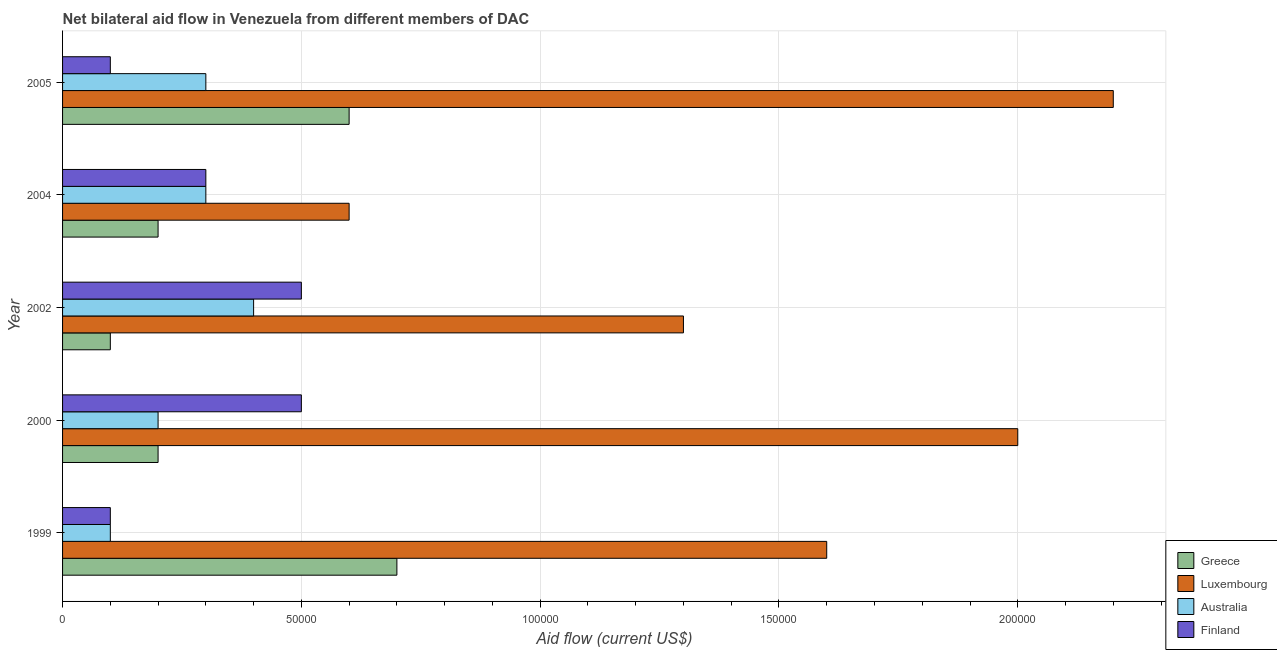How many different coloured bars are there?
Your answer should be compact. 4. Are the number of bars per tick equal to the number of legend labels?
Your answer should be compact. Yes. Are the number of bars on each tick of the Y-axis equal?
Your response must be concise. Yes. How many bars are there on the 1st tick from the bottom?
Offer a very short reply. 4. What is the label of the 1st group of bars from the top?
Provide a short and direct response. 2005. In how many cases, is the number of bars for a given year not equal to the number of legend labels?
Provide a short and direct response. 0. What is the amount of aid given by luxembourg in 2004?
Provide a short and direct response. 6.00e+04. Across all years, what is the maximum amount of aid given by greece?
Ensure brevity in your answer.  7.00e+04. Across all years, what is the minimum amount of aid given by australia?
Provide a succinct answer. 10000. What is the total amount of aid given by australia in the graph?
Provide a short and direct response. 1.30e+05. What is the difference between the amount of aid given by australia in 1999 and that in 2005?
Keep it short and to the point. -2.00e+04. What is the difference between the amount of aid given by finland in 2000 and the amount of aid given by greece in 1999?
Make the answer very short. -2.00e+04. In the year 2002, what is the difference between the amount of aid given by finland and amount of aid given by greece?
Provide a short and direct response. 4.00e+04. Is the difference between the amount of aid given by australia in 2000 and 2002 greater than the difference between the amount of aid given by finland in 2000 and 2002?
Offer a very short reply. No. What is the difference between the highest and the second highest amount of aid given by greece?
Offer a terse response. 10000. What is the difference between the highest and the lowest amount of aid given by greece?
Your answer should be compact. 6.00e+04. Is it the case that in every year, the sum of the amount of aid given by greece and amount of aid given by australia is greater than the sum of amount of aid given by finland and amount of aid given by luxembourg?
Offer a terse response. No. How many years are there in the graph?
Provide a succinct answer. 5. What is the difference between two consecutive major ticks on the X-axis?
Your answer should be compact. 5.00e+04. Does the graph contain any zero values?
Provide a short and direct response. No. Where does the legend appear in the graph?
Provide a succinct answer. Bottom right. How are the legend labels stacked?
Offer a very short reply. Vertical. What is the title of the graph?
Make the answer very short. Net bilateral aid flow in Venezuela from different members of DAC. What is the label or title of the Y-axis?
Make the answer very short. Year. What is the Aid flow (current US$) of Australia in 1999?
Your response must be concise. 10000. What is the Aid flow (current US$) of Finland in 1999?
Provide a short and direct response. 10000. What is the Aid flow (current US$) in Greece in 2000?
Provide a succinct answer. 2.00e+04. What is the Aid flow (current US$) in Australia in 2000?
Your response must be concise. 2.00e+04. What is the Aid flow (current US$) of Finland in 2000?
Provide a succinct answer. 5.00e+04. What is the Aid flow (current US$) of Luxembourg in 2002?
Your answer should be very brief. 1.30e+05. What is the Aid flow (current US$) in Finland in 2002?
Provide a short and direct response. 5.00e+04. What is the Aid flow (current US$) of Luxembourg in 2004?
Offer a very short reply. 6.00e+04. What is the Aid flow (current US$) in Finland in 2004?
Offer a terse response. 3.00e+04. What is the Aid flow (current US$) in Luxembourg in 2005?
Offer a very short reply. 2.20e+05. What is the Aid flow (current US$) of Australia in 2005?
Your answer should be compact. 3.00e+04. What is the Aid flow (current US$) of Finland in 2005?
Your answer should be compact. 10000. Across all years, what is the maximum Aid flow (current US$) in Australia?
Make the answer very short. 4.00e+04. Across all years, what is the maximum Aid flow (current US$) in Finland?
Offer a terse response. 5.00e+04. Across all years, what is the minimum Aid flow (current US$) in Luxembourg?
Offer a very short reply. 6.00e+04. Across all years, what is the minimum Aid flow (current US$) of Finland?
Offer a terse response. 10000. What is the total Aid flow (current US$) in Luxembourg in the graph?
Offer a terse response. 7.70e+05. What is the total Aid flow (current US$) in Finland in the graph?
Make the answer very short. 1.50e+05. What is the difference between the Aid flow (current US$) in Greece in 1999 and that in 2000?
Your response must be concise. 5.00e+04. What is the difference between the Aid flow (current US$) of Finland in 1999 and that in 2000?
Give a very brief answer. -4.00e+04. What is the difference between the Aid flow (current US$) in Luxembourg in 1999 and that in 2002?
Offer a very short reply. 3.00e+04. What is the difference between the Aid flow (current US$) of Australia in 1999 and that in 2005?
Ensure brevity in your answer.  -2.00e+04. What is the difference between the Aid flow (current US$) of Greece in 2000 and that in 2002?
Offer a very short reply. 10000. What is the difference between the Aid flow (current US$) in Finland in 2000 and that in 2002?
Make the answer very short. 0. What is the difference between the Aid flow (current US$) in Greece in 2000 and that in 2004?
Make the answer very short. 0. What is the difference between the Aid flow (current US$) in Luxembourg in 2000 and that in 2004?
Offer a terse response. 1.40e+05. What is the difference between the Aid flow (current US$) of Australia in 2000 and that in 2004?
Your answer should be very brief. -10000. What is the difference between the Aid flow (current US$) in Finland in 2000 and that in 2004?
Make the answer very short. 2.00e+04. What is the difference between the Aid flow (current US$) in Greece in 2000 and that in 2005?
Keep it short and to the point. -4.00e+04. What is the difference between the Aid flow (current US$) in Luxembourg in 2000 and that in 2005?
Your response must be concise. -2.00e+04. What is the difference between the Aid flow (current US$) in Finland in 2000 and that in 2005?
Your answer should be compact. 4.00e+04. What is the difference between the Aid flow (current US$) of Greece in 2002 and that in 2004?
Your answer should be very brief. -10000. What is the difference between the Aid flow (current US$) in Australia in 2002 and that in 2004?
Your answer should be very brief. 10000. What is the difference between the Aid flow (current US$) of Greece in 2002 and that in 2005?
Ensure brevity in your answer.  -5.00e+04. What is the difference between the Aid flow (current US$) of Luxembourg in 2002 and that in 2005?
Your answer should be very brief. -9.00e+04. What is the difference between the Aid flow (current US$) in Australia in 2002 and that in 2005?
Offer a very short reply. 10000. What is the difference between the Aid flow (current US$) of Finland in 2002 and that in 2005?
Your response must be concise. 4.00e+04. What is the difference between the Aid flow (current US$) of Greece in 2004 and that in 2005?
Offer a terse response. -4.00e+04. What is the difference between the Aid flow (current US$) of Luxembourg in 2004 and that in 2005?
Make the answer very short. -1.60e+05. What is the difference between the Aid flow (current US$) of Australia in 2004 and that in 2005?
Your answer should be very brief. 0. What is the difference between the Aid flow (current US$) in Greece in 1999 and the Aid flow (current US$) in Australia in 2000?
Your answer should be very brief. 5.00e+04. What is the difference between the Aid flow (current US$) in Luxembourg in 1999 and the Aid flow (current US$) in Finland in 2000?
Make the answer very short. 1.10e+05. What is the difference between the Aid flow (current US$) of Greece in 1999 and the Aid flow (current US$) of Luxembourg in 2002?
Offer a terse response. -6.00e+04. What is the difference between the Aid flow (current US$) of Australia in 1999 and the Aid flow (current US$) of Finland in 2002?
Your response must be concise. -4.00e+04. What is the difference between the Aid flow (current US$) of Greece in 1999 and the Aid flow (current US$) of Luxembourg in 2004?
Make the answer very short. 10000. What is the difference between the Aid flow (current US$) in Greece in 1999 and the Aid flow (current US$) in Australia in 2004?
Your answer should be compact. 4.00e+04. What is the difference between the Aid flow (current US$) in Greece in 1999 and the Aid flow (current US$) in Finland in 2004?
Offer a very short reply. 4.00e+04. What is the difference between the Aid flow (current US$) of Luxembourg in 1999 and the Aid flow (current US$) of Finland in 2004?
Your answer should be compact. 1.30e+05. What is the difference between the Aid flow (current US$) of Greece in 1999 and the Aid flow (current US$) of Luxembourg in 2005?
Your answer should be compact. -1.50e+05. What is the difference between the Aid flow (current US$) in Greece in 1999 and the Aid flow (current US$) in Australia in 2005?
Offer a terse response. 4.00e+04. What is the difference between the Aid flow (current US$) of Greece in 1999 and the Aid flow (current US$) of Finland in 2005?
Offer a terse response. 6.00e+04. What is the difference between the Aid flow (current US$) of Luxembourg in 1999 and the Aid flow (current US$) of Finland in 2005?
Keep it short and to the point. 1.50e+05. What is the difference between the Aid flow (current US$) in Greece in 2000 and the Aid flow (current US$) in Luxembourg in 2002?
Your answer should be very brief. -1.10e+05. What is the difference between the Aid flow (current US$) in Luxembourg in 2000 and the Aid flow (current US$) in Finland in 2002?
Your answer should be compact. 1.50e+05. What is the difference between the Aid flow (current US$) of Australia in 2000 and the Aid flow (current US$) of Finland in 2002?
Keep it short and to the point. -3.00e+04. What is the difference between the Aid flow (current US$) in Greece in 2000 and the Aid flow (current US$) in Australia in 2004?
Make the answer very short. -10000. What is the difference between the Aid flow (current US$) in Greece in 2000 and the Aid flow (current US$) in Finland in 2004?
Offer a very short reply. -10000. What is the difference between the Aid flow (current US$) of Luxembourg in 2000 and the Aid flow (current US$) of Australia in 2004?
Offer a terse response. 1.70e+05. What is the difference between the Aid flow (current US$) in Luxembourg in 2000 and the Aid flow (current US$) in Finland in 2004?
Your answer should be very brief. 1.70e+05. What is the difference between the Aid flow (current US$) of Greece in 2000 and the Aid flow (current US$) of Luxembourg in 2005?
Give a very brief answer. -2.00e+05. What is the difference between the Aid flow (current US$) of Greece in 2000 and the Aid flow (current US$) of Australia in 2005?
Ensure brevity in your answer.  -10000. What is the difference between the Aid flow (current US$) in Greece in 2002 and the Aid flow (current US$) in Luxembourg in 2004?
Give a very brief answer. -5.00e+04. What is the difference between the Aid flow (current US$) of Greece in 2002 and the Aid flow (current US$) of Australia in 2004?
Provide a succinct answer. -2.00e+04. What is the difference between the Aid flow (current US$) in Greece in 2002 and the Aid flow (current US$) in Finland in 2004?
Provide a short and direct response. -2.00e+04. What is the difference between the Aid flow (current US$) of Luxembourg in 2002 and the Aid flow (current US$) of Finland in 2004?
Make the answer very short. 1.00e+05. What is the difference between the Aid flow (current US$) in Greece in 2002 and the Aid flow (current US$) in Luxembourg in 2005?
Give a very brief answer. -2.10e+05. What is the difference between the Aid flow (current US$) of Greece in 2002 and the Aid flow (current US$) of Australia in 2005?
Offer a very short reply. -2.00e+04. What is the difference between the Aid flow (current US$) in Greece in 2002 and the Aid flow (current US$) in Finland in 2005?
Your answer should be compact. 0. What is the difference between the Aid flow (current US$) of Luxembourg in 2002 and the Aid flow (current US$) of Finland in 2005?
Provide a succinct answer. 1.20e+05. What is the difference between the Aid flow (current US$) in Australia in 2002 and the Aid flow (current US$) in Finland in 2005?
Keep it short and to the point. 3.00e+04. What is the difference between the Aid flow (current US$) of Greece in 2004 and the Aid flow (current US$) of Luxembourg in 2005?
Your response must be concise. -2.00e+05. What is the difference between the Aid flow (current US$) in Australia in 2004 and the Aid flow (current US$) in Finland in 2005?
Offer a very short reply. 2.00e+04. What is the average Aid flow (current US$) of Greece per year?
Your answer should be very brief. 3.60e+04. What is the average Aid flow (current US$) of Luxembourg per year?
Ensure brevity in your answer.  1.54e+05. What is the average Aid flow (current US$) in Australia per year?
Your response must be concise. 2.60e+04. In the year 1999, what is the difference between the Aid flow (current US$) of Greece and Aid flow (current US$) of Finland?
Give a very brief answer. 6.00e+04. In the year 2000, what is the difference between the Aid flow (current US$) of Greece and Aid flow (current US$) of Luxembourg?
Provide a short and direct response. -1.80e+05. In the year 2000, what is the difference between the Aid flow (current US$) in Greece and Aid flow (current US$) in Australia?
Your answer should be very brief. 0. In the year 2000, what is the difference between the Aid flow (current US$) in Australia and Aid flow (current US$) in Finland?
Give a very brief answer. -3.00e+04. In the year 2002, what is the difference between the Aid flow (current US$) in Greece and Aid flow (current US$) in Luxembourg?
Provide a short and direct response. -1.20e+05. In the year 2002, what is the difference between the Aid flow (current US$) in Luxembourg and Aid flow (current US$) in Australia?
Make the answer very short. 9.00e+04. In the year 2002, what is the difference between the Aid flow (current US$) in Australia and Aid flow (current US$) in Finland?
Provide a short and direct response. -10000. In the year 2004, what is the difference between the Aid flow (current US$) in Greece and Aid flow (current US$) in Australia?
Your response must be concise. -10000. In the year 2004, what is the difference between the Aid flow (current US$) in Luxembourg and Aid flow (current US$) in Finland?
Provide a short and direct response. 3.00e+04. In the year 2004, what is the difference between the Aid flow (current US$) in Australia and Aid flow (current US$) in Finland?
Your answer should be compact. 0. In the year 2005, what is the difference between the Aid flow (current US$) of Greece and Aid flow (current US$) of Australia?
Ensure brevity in your answer.  3.00e+04. In the year 2005, what is the difference between the Aid flow (current US$) of Luxembourg and Aid flow (current US$) of Finland?
Offer a terse response. 2.10e+05. What is the ratio of the Aid flow (current US$) in Luxembourg in 1999 to that in 2000?
Your answer should be very brief. 0.8. What is the ratio of the Aid flow (current US$) of Australia in 1999 to that in 2000?
Make the answer very short. 0.5. What is the ratio of the Aid flow (current US$) in Greece in 1999 to that in 2002?
Provide a succinct answer. 7. What is the ratio of the Aid flow (current US$) in Luxembourg in 1999 to that in 2002?
Ensure brevity in your answer.  1.23. What is the ratio of the Aid flow (current US$) in Australia in 1999 to that in 2002?
Provide a succinct answer. 0.25. What is the ratio of the Aid flow (current US$) in Finland in 1999 to that in 2002?
Make the answer very short. 0.2. What is the ratio of the Aid flow (current US$) of Greece in 1999 to that in 2004?
Give a very brief answer. 3.5. What is the ratio of the Aid flow (current US$) in Luxembourg in 1999 to that in 2004?
Ensure brevity in your answer.  2.67. What is the ratio of the Aid flow (current US$) in Finland in 1999 to that in 2004?
Make the answer very short. 0.33. What is the ratio of the Aid flow (current US$) in Greece in 1999 to that in 2005?
Make the answer very short. 1.17. What is the ratio of the Aid flow (current US$) in Luxembourg in 1999 to that in 2005?
Make the answer very short. 0.73. What is the ratio of the Aid flow (current US$) in Finland in 1999 to that in 2005?
Provide a short and direct response. 1. What is the ratio of the Aid flow (current US$) in Greece in 2000 to that in 2002?
Offer a very short reply. 2. What is the ratio of the Aid flow (current US$) in Luxembourg in 2000 to that in 2002?
Your response must be concise. 1.54. What is the ratio of the Aid flow (current US$) in Australia in 2000 to that in 2002?
Provide a succinct answer. 0.5. What is the ratio of the Aid flow (current US$) of Greece in 2000 to that in 2005?
Your answer should be very brief. 0.33. What is the ratio of the Aid flow (current US$) in Luxembourg in 2000 to that in 2005?
Provide a succinct answer. 0.91. What is the ratio of the Aid flow (current US$) of Finland in 2000 to that in 2005?
Offer a terse response. 5. What is the ratio of the Aid flow (current US$) of Greece in 2002 to that in 2004?
Offer a very short reply. 0.5. What is the ratio of the Aid flow (current US$) in Luxembourg in 2002 to that in 2004?
Provide a short and direct response. 2.17. What is the ratio of the Aid flow (current US$) of Finland in 2002 to that in 2004?
Make the answer very short. 1.67. What is the ratio of the Aid flow (current US$) of Greece in 2002 to that in 2005?
Keep it short and to the point. 0.17. What is the ratio of the Aid flow (current US$) in Luxembourg in 2002 to that in 2005?
Offer a terse response. 0.59. What is the ratio of the Aid flow (current US$) in Australia in 2002 to that in 2005?
Offer a very short reply. 1.33. What is the ratio of the Aid flow (current US$) in Luxembourg in 2004 to that in 2005?
Your response must be concise. 0.27. What is the difference between the highest and the second highest Aid flow (current US$) in Finland?
Provide a short and direct response. 0. What is the difference between the highest and the lowest Aid flow (current US$) of Greece?
Your answer should be compact. 6.00e+04. What is the difference between the highest and the lowest Aid flow (current US$) of Australia?
Give a very brief answer. 3.00e+04. 